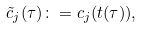Convert formula to latex. <formula><loc_0><loc_0><loc_500><loc_500>\tilde { c } _ { j } ( \tau ) \colon = c _ { j } ( t ( \tau ) ) ,</formula> 